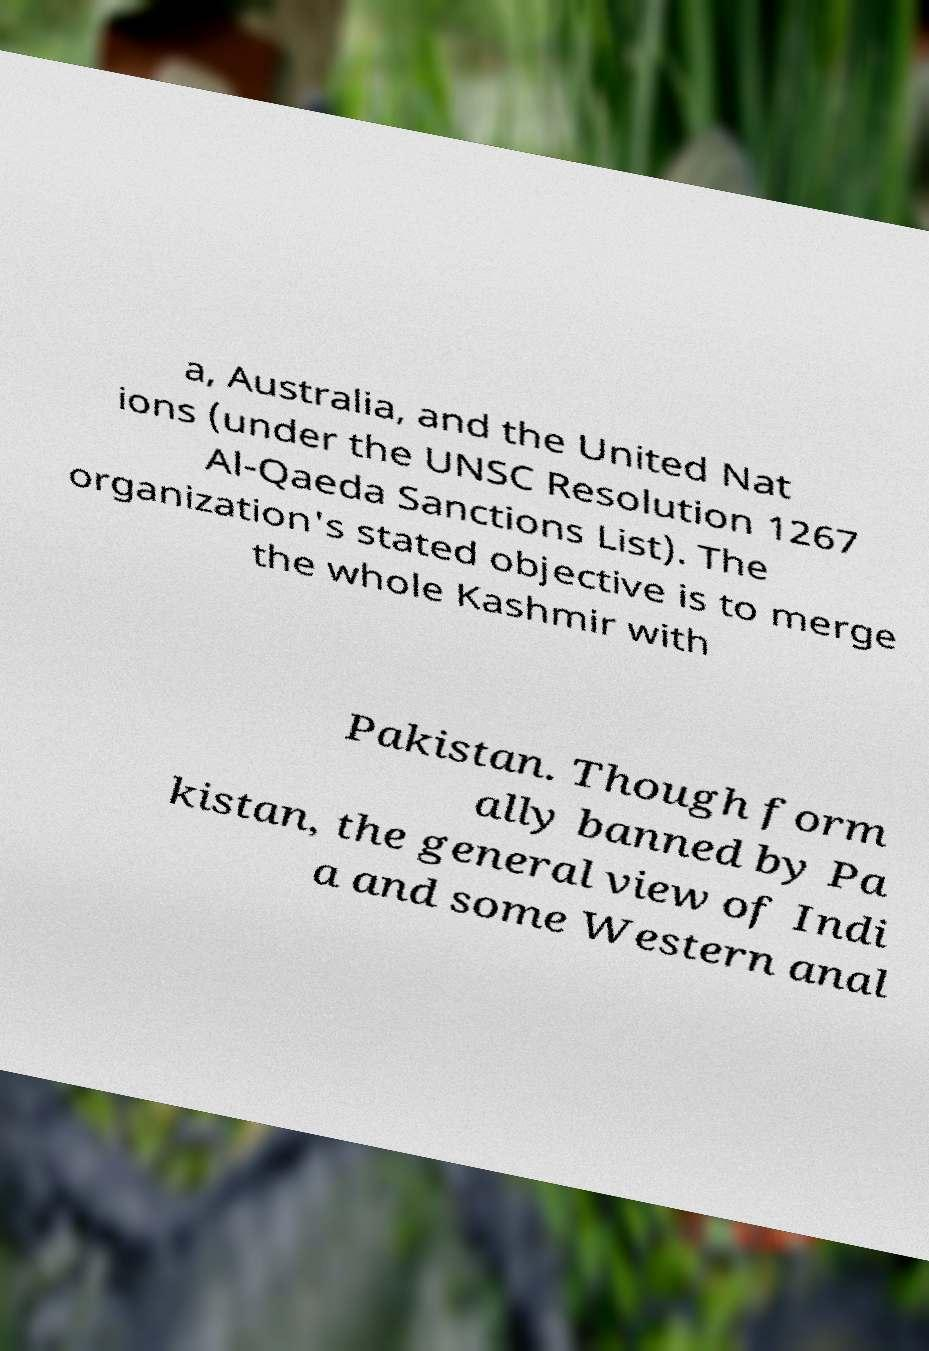What messages or text are displayed in this image? I need them in a readable, typed format. a, Australia, and the United Nat ions (under the UNSC Resolution 1267 Al-Qaeda Sanctions List). The organization's stated objective is to merge the whole Kashmir with Pakistan. Though form ally banned by Pa kistan, the general view of Indi a and some Western anal 